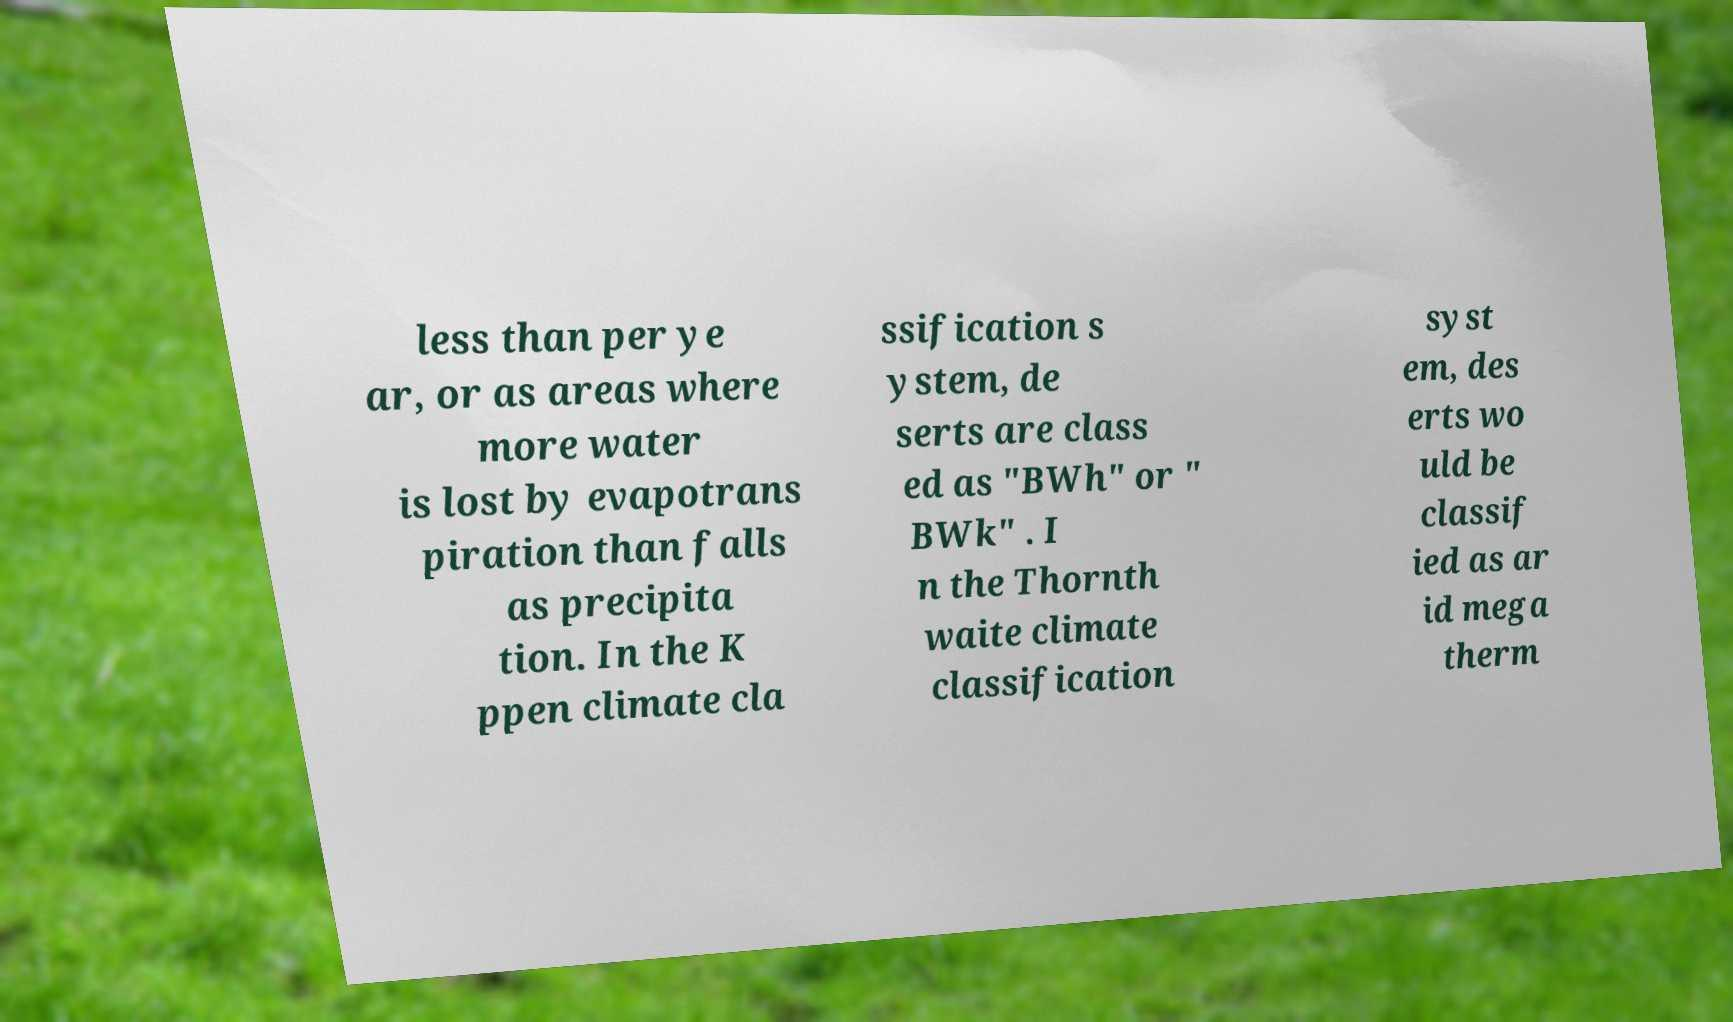Please read and relay the text visible in this image. What does it say? less than per ye ar, or as areas where more water is lost by evapotrans piration than falls as precipita tion. In the K ppen climate cla ssification s ystem, de serts are class ed as "BWh" or " BWk" . I n the Thornth waite climate classification syst em, des erts wo uld be classif ied as ar id mega therm 